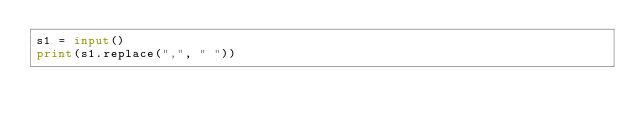Convert code to text. <code><loc_0><loc_0><loc_500><loc_500><_Python_>s1 = input()
print(s1.replace(",", " "))</code> 